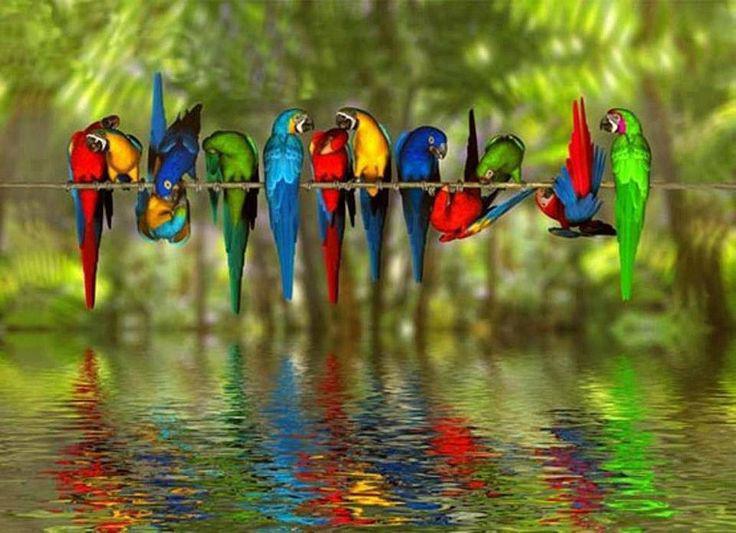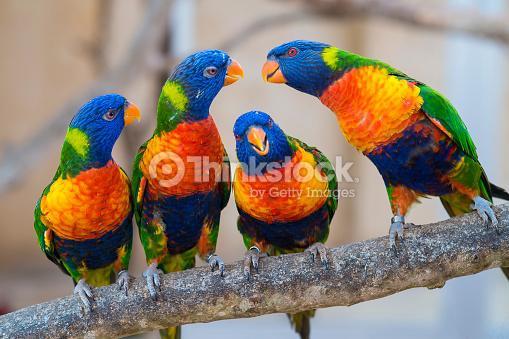The first image is the image on the left, the second image is the image on the right. Analyze the images presented: Is the assertion "One of the images has only two parrots." valid? Answer yes or no. No. The first image is the image on the left, the second image is the image on the right. Assess this claim about the two images: "There are at least 2 blue-headed parrots.". Correct or not? Answer yes or no. Yes. 